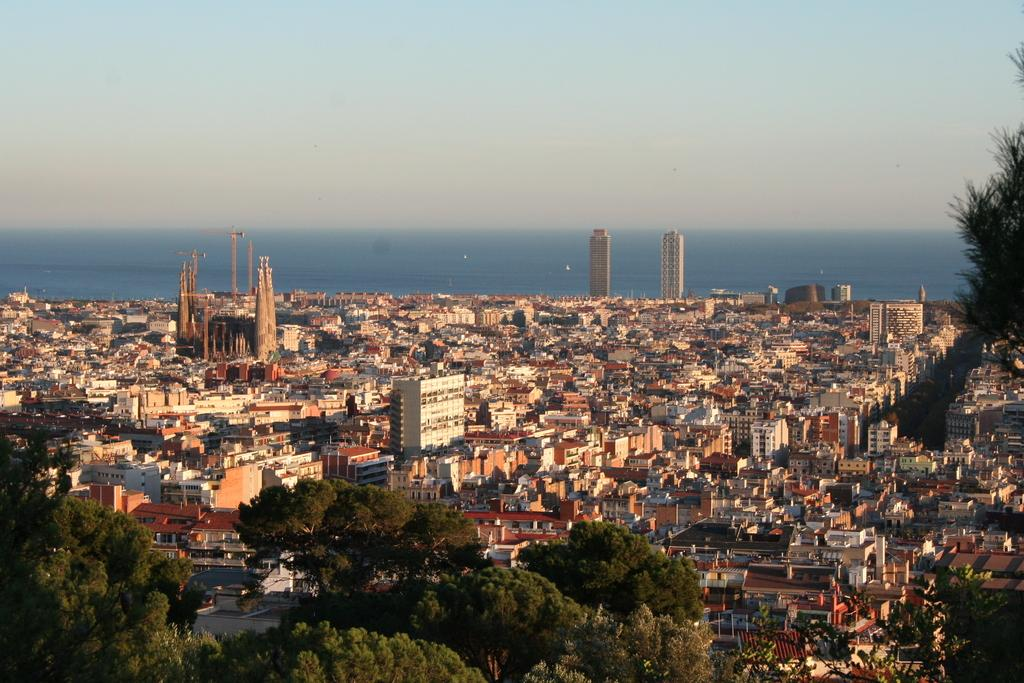What type of structures can be seen in the image? There are buildings, towers, and poles in the image. What else can be seen in the image besides structures? There are trees and vehicles in the image. What is visible at the top of the image? The sky is visible at the top of the image. What type of religion is practiced in the image? There is no indication of any religious practice or belief in the image. What is the noise level in the image? The image does not provide any information about the noise level. 